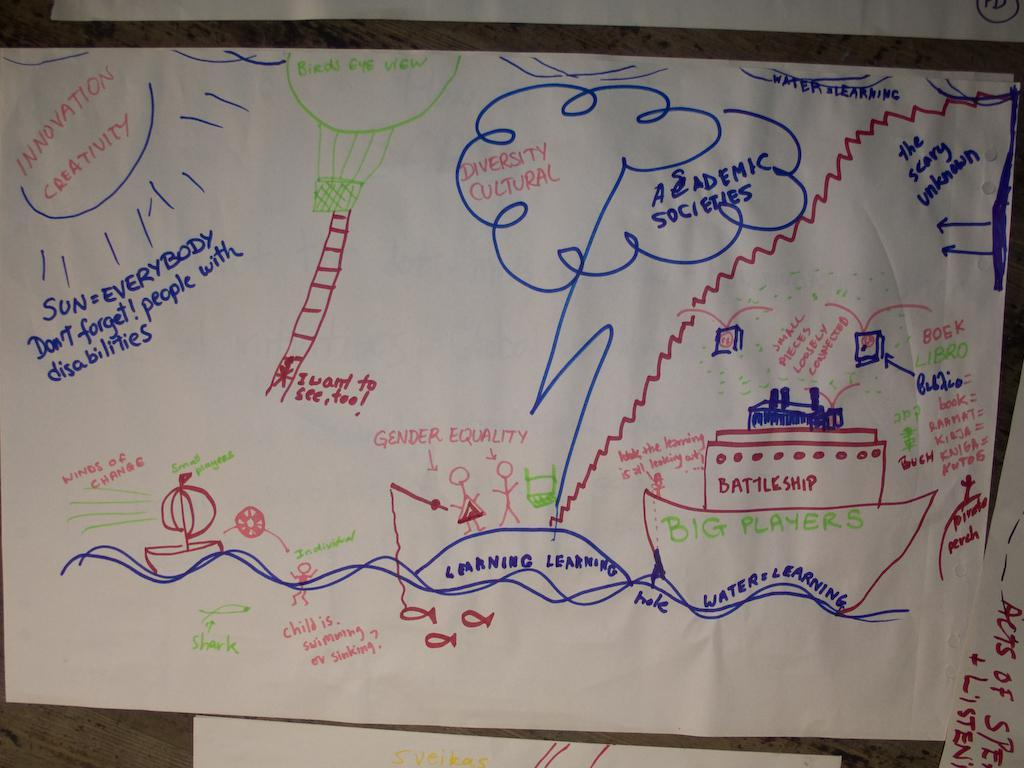<image>
Provide a brief description of the given image. A drawing of people fishing and a battleship called big players. 